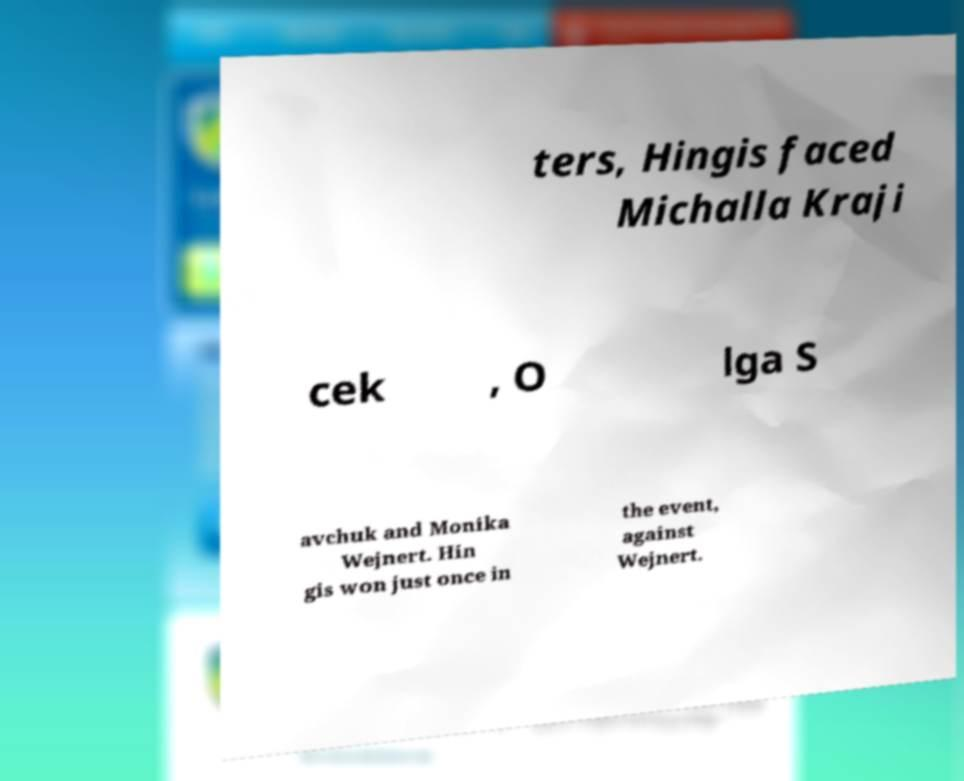Can you accurately transcribe the text from the provided image for me? ters, Hingis faced Michalla Kraji cek , O lga S avchuk and Monika Wejnert. Hin gis won just once in the event, against Wejnert. 